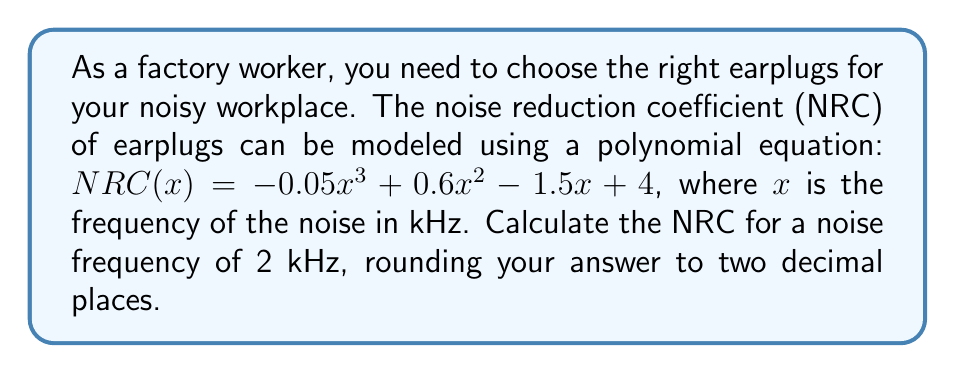Teach me how to tackle this problem. To solve this problem, we'll follow these steps:

1) We're given the polynomial equation for the Noise Reduction Coefficient (NRC):
   $$NRC(x) = -0.05x^3 + 0.6x^2 - 1.5x + 4$$

2) We need to find NRC(2), as the noise frequency is 2 kHz:
   $$NRC(2) = -0.05(2)^3 + 0.6(2)^2 - 1.5(2) + 4$$

3) Let's calculate each term:
   - $-0.05(2)^3 = -0.05 \cdot 8 = -0.4$
   - $0.6(2)^2 = 0.6 \cdot 4 = 2.4$
   - $-1.5(2) = -3$
   - The constant term is 4

4) Now, let's sum these terms:
   $$NRC(2) = -0.4 + 2.4 - 3 + 4 = 3$$

5) The question asks for the answer rounded to two decimal places. Since 3 is already a whole number, it remains 3.00 when rounded to two decimal places.
Answer: 3.00 